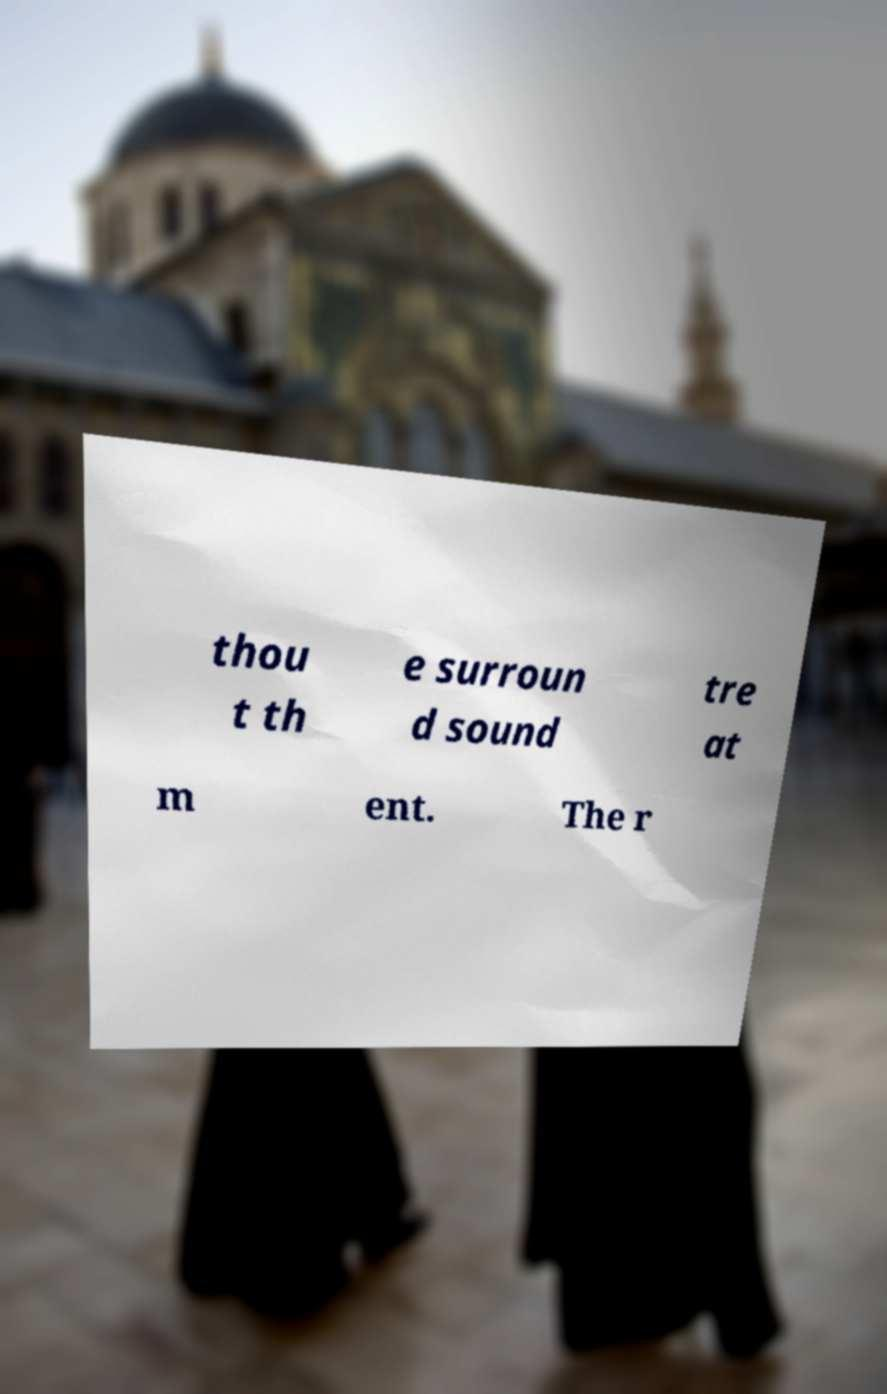Please read and relay the text visible in this image. What does it say? thou t th e surroun d sound tre at m ent. The r 